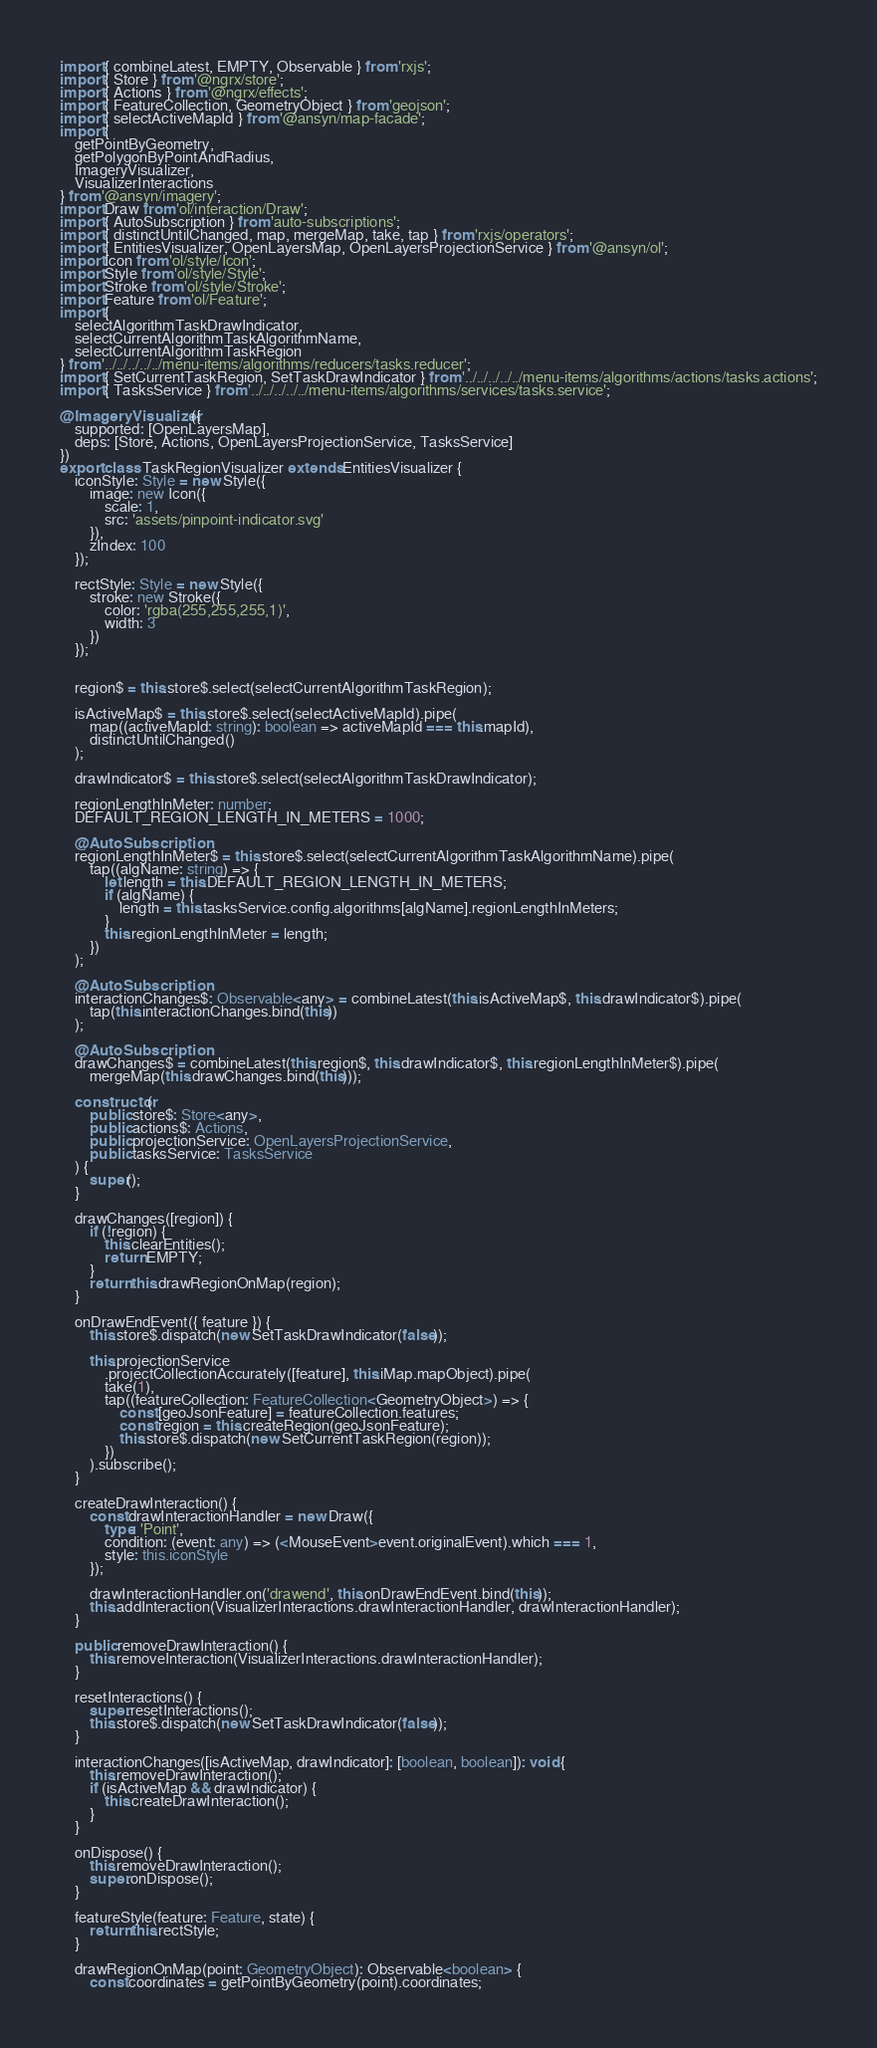<code> <loc_0><loc_0><loc_500><loc_500><_TypeScript_>import { combineLatest, EMPTY, Observable } from 'rxjs';
import { Store } from '@ngrx/store';
import { Actions } from '@ngrx/effects';
import { FeatureCollection, GeometryObject } from 'geojson';
import { selectActiveMapId } from '@ansyn/map-facade';
import {
	getPointByGeometry,
	getPolygonByPointAndRadius,
	ImageryVisualizer,
	VisualizerInteractions
} from '@ansyn/imagery';
import Draw from 'ol/interaction/Draw';
import { AutoSubscription } from 'auto-subscriptions';
import { distinctUntilChanged, map, mergeMap, take, tap } from 'rxjs/operators';
import { EntitiesVisualizer, OpenLayersMap, OpenLayersProjectionService } from '@ansyn/ol';
import Icon from 'ol/style/Icon';
import Style from 'ol/style/Style';
import Stroke from 'ol/style/Stroke';
import Feature from 'ol/Feature';
import {
	selectAlgorithmTaskDrawIndicator,
	selectCurrentAlgorithmTaskAlgorithmName,
	selectCurrentAlgorithmTaskRegion
} from '../../../../../menu-items/algorithms/reducers/tasks.reducer';
import { SetCurrentTaskRegion, SetTaskDrawIndicator } from '../../../../../menu-items/algorithms/actions/tasks.actions';
import { TasksService } from '../../../../../menu-items/algorithms/services/tasks.service';

@ImageryVisualizer({
	supported: [OpenLayersMap],
	deps: [Store, Actions, OpenLayersProjectionService, TasksService]
})
export class TaskRegionVisualizer extends EntitiesVisualizer {
	iconStyle: Style = new Style({
		image: new Icon({
			scale: 1,
			src: 'assets/pinpoint-indicator.svg'
		}),
		zIndex: 100
	});

	rectStyle: Style = new Style({
		stroke: new Stroke({
			color: 'rgba(255,255,255,1)',
			width: 3
		})
	});


	region$ = this.store$.select(selectCurrentAlgorithmTaskRegion);

	isActiveMap$ = this.store$.select(selectActiveMapId).pipe(
		map((activeMapId: string): boolean => activeMapId === this.mapId),
		distinctUntilChanged()
	);

	drawIndicator$ = this.store$.select(selectAlgorithmTaskDrawIndicator);

	regionLengthInMeter: number;
	DEFAULT_REGION_LENGTH_IN_METERS = 1000;

	@AutoSubscription
	regionLengthInMeter$ = this.store$.select(selectCurrentAlgorithmTaskAlgorithmName).pipe(
		tap((algName: string) => {
			let length = this.DEFAULT_REGION_LENGTH_IN_METERS;
			if (algName) {
				length = this.tasksService.config.algorithms[algName].regionLengthInMeters;
			}
			this.regionLengthInMeter = length;
		})
	);

	@AutoSubscription
	interactionChanges$: Observable<any> = combineLatest(this.isActiveMap$, this.drawIndicator$).pipe(
		tap(this.interactionChanges.bind(this))
	);

	@AutoSubscription
	drawChanges$ = combineLatest(this.region$, this.drawIndicator$, this.regionLengthInMeter$).pipe(
		mergeMap(this.drawChanges.bind(this)));

	constructor(
		public store$: Store<any>,
		public actions$: Actions,
		public projectionService: OpenLayersProjectionService,
		public tasksService: TasksService
	) {
		super();
	}

	drawChanges([region]) {
		if (!region) {
			this.clearEntities();
			return EMPTY;
		}
		return this.drawRegionOnMap(region);
	}

	onDrawEndEvent({ feature }) {
		this.store$.dispatch(new SetTaskDrawIndicator(false));

		this.projectionService
			.projectCollectionAccurately([feature], this.iMap.mapObject).pipe(
			take(1),
			tap((featureCollection: FeatureCollection<GeometryObject>) => {
				const [geoJsonFeature] = featureCollection.features;
				const region = this.createRegion(geoJsonFeature);
				this.store$.dispatch(new SetCurrentTaskRegion(region));
			})
		).subscribe();
	}

	createDrawInteraction() {
		const drawInteractionHandler = new Draw({
			type: 'Point',
			condition: (event: any) => (<MouseEvent>event.originalEvent).which === 1,
			style: this.iconStyle
		});

		drawInteractionHandler.on('drawend', this.onDrawEndEvent.bind(this));
		this.addInteraction(VisualizerInteractions.drawInteractionHandler, drawInteractionHandler);
	}

	public removeDrawInteraction() {
		this.removeInteraction(VisualizerInteractions.drawInteractionHandler);
	}

	resetInteractions() {
		super.resetInteractions();
		this.store$.dispatch(new SetTaskDrawIndicator(false));
	}

	interactionChanges([isActiveMap, drawIndicator]: [boolean, boolean]): void {
		this.removeDrawInteraction();
		if (isActiveMap && drawIndicator) {
			this.createDrawInteraction();
		}
	}

	onDispose() {
		this.removeDrawInteraction();
		super.onDispose();
	}

	featureStyle(feature: Feature, state) {
		return this.rectStyle;
	}

	drawRegionOnMap(point: GeometryObject): Observable<boolean> {
		const coordinates = getPointByGeometry(point).coordinates;</code> 